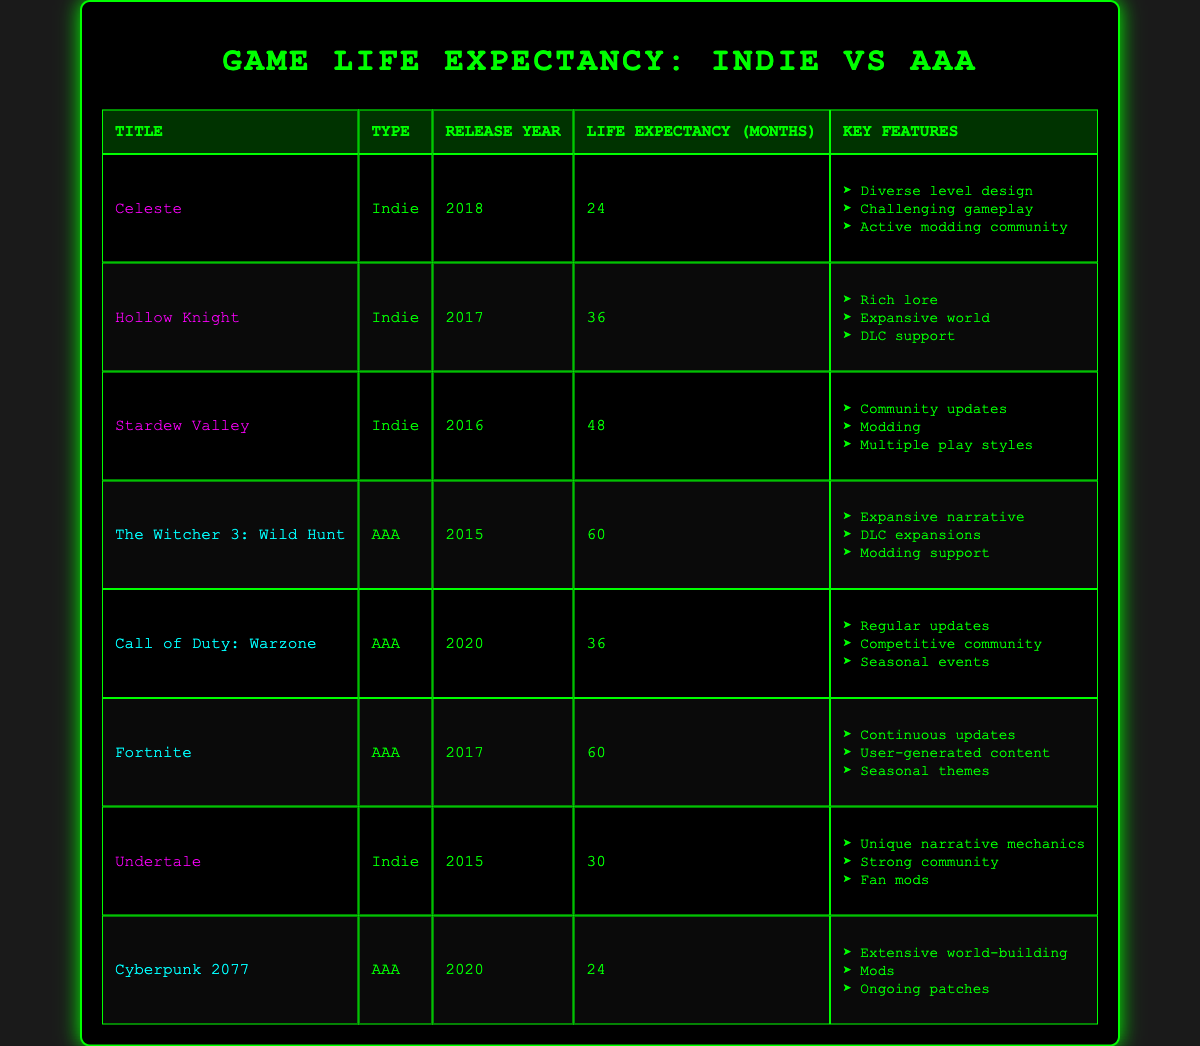What is the life expectancy of "Celeste"? The table lists the life expectancy of "Celeste" under the column for life expectancy months, which shows a value of 24.
Answer: 24 Which game has the highest life expectancy? By reviewing the life expectancy months for each game, "The Witcher 3: Wild Hunt" has the highest life expectancy at 60 months.
Answer: The Witcher 3: Wild Hunt How many months do the AAA games last on average? To find the average life expectancy of AAA games, we add their life expectancies: 60 + 36 + 60 + 24 = 180. There are four AAA games, so the average is 180 divided by 4, which equals 45.
Answer: 45 Is "Stardew Valley" an AAA title? By checking the type column for "Stardew Valley," it is categorized as "Indie," which confirms it is not an AAA title.
Answer: No Which indie game has a life expectancy greater than 30 months? By examining the life expectancy of each indie game, "Hollow Knight" at 36 months and "Stardew Valley" at 48 months are both greater than 30 months.
Answer: Hollow Knight, Stardew Valley What is the difference in life expectancy between "Cyberpunk 2077" and "Call of Duty: Warzone"? "Cyberpunk 2077" has a life expectancy of 24 months, and "Call of Duty: Warzone" has a life expectancy of 36 months. The difference is 36 minus 24, which gives us a result of 12 months.
Answer: 12 Which game types have the most titles listed in the table? The table contains four indie titles (Celeste, Hollow Knight, Stardew Valley, Undertale) and four AAA titles (The Witcher 3: Wild Hunt, Call of Duty: Warzone, Fortnite, Cyberpunk 2077). Both types have an equal number of titles.
Answer: Both have equal titles How many months do "Fortnite" and "Hollow Knight" last together? "Fortnite" has a life expectancy of 60 months and "Hollow Knight" has a life expectancy of 36 months. Adding these gives us 60 plus 36, resulting in a total of 96 months.
Answer: 96 Is "Undertale" released later than "Hollow Knight"? "Undertale" was released in 2015, while "Hollow Knight" was released in 2017. Since 2015 is before 2017, the statement is false.
Answer: No 